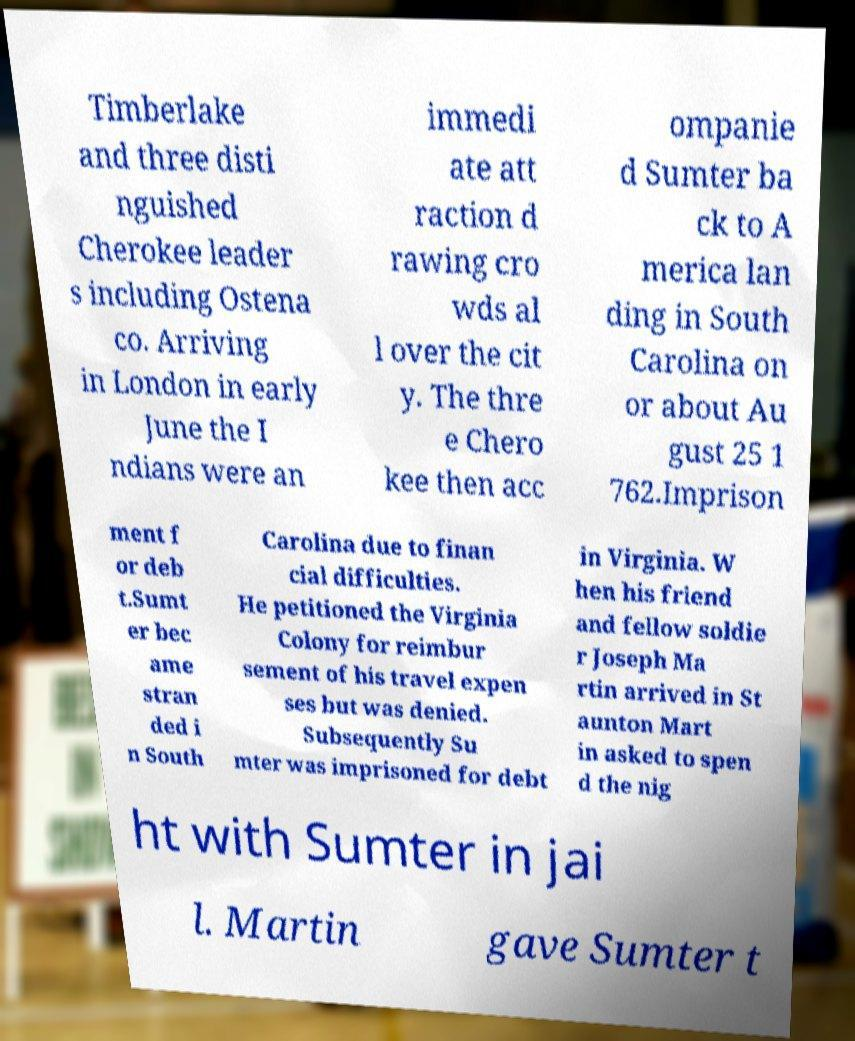For documentation purposes, I need the text within this image transcribed. Could you provide that? Timberlake and three disti nguished Cherokee leader s including Ostena co. Arriving in London in early June the I ndians were an immedi ate att raction d rawing cro wds al l over the cit y. The thre e Chero kee then acc ompanie d Sumter ba ck to A merica lan ding in South Carolina on or about Au gust 25 1 762.Imprison ment f or deb t.Sumt er bec ame stran ded i n South Carolina due to finan cial difficulties. He petitioned the Virginia Colony for reimbur sement of his travel expen ses but was denied. Subsequently Su mter was imprisoned for debt in Virginia. W hen his friend and fellow soldie r Joseph Ma rtin arrived in St aunton Mart in asked to spen d the nig ht with Sumter in jai l. Martin gave Sumter t 